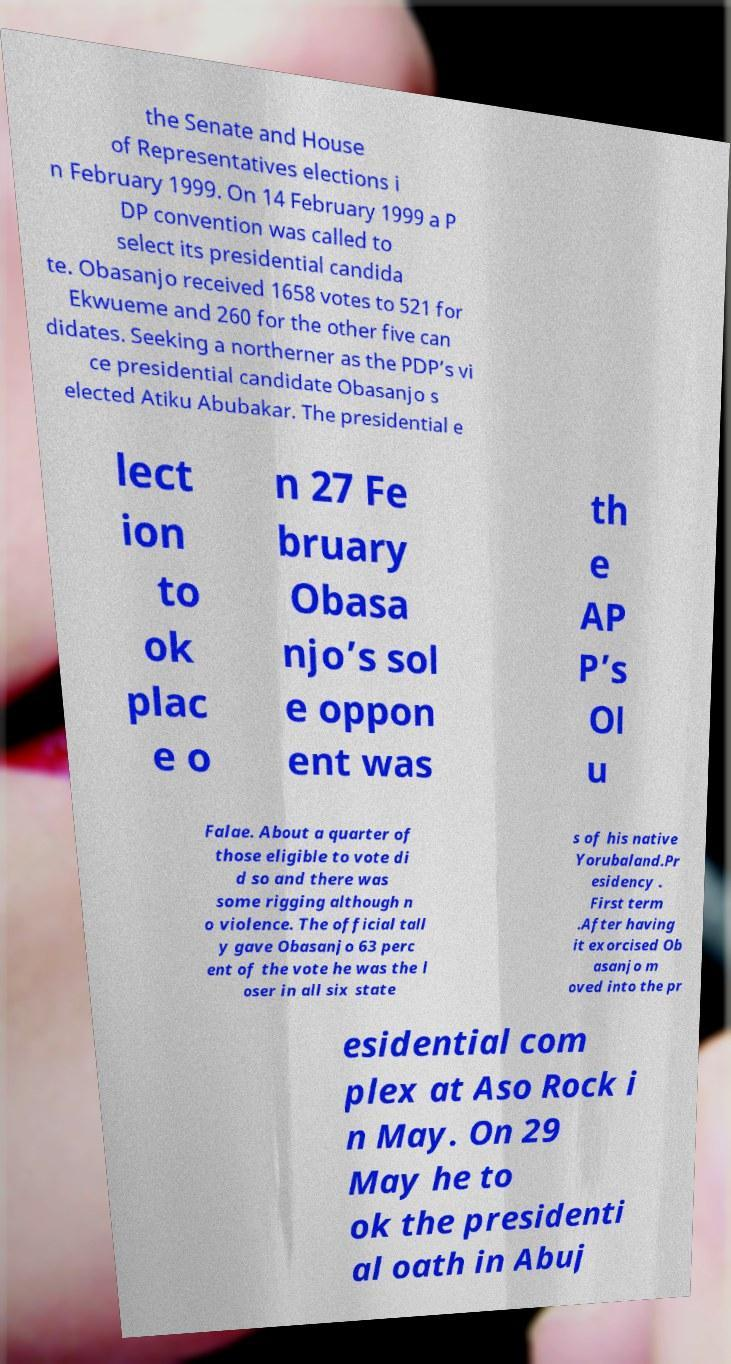What messages or text are displayed in this image? I need them in a readable, typed format. the Senate and House of Representatives elections i n February 1999. On 14 February 1999 a P DP convention was called to select its presidential candida te. Obasanjo received 1658 votes to 521 for Ekwueme and 260 for the other five can didates. Seeking a northerner as the PDP’s vi ce presidential candidate Obasanjo s elected Atiku Abubakar. The presidential e lect ion to ok plac e o n 27 Fe bruary Obasa njo’s sol e oppon ent was th e AP P’s Ol u Falae. About a quarter of those eligible to vote di d so and there was some rigging although n o violence. The official tall y gave Obasanjo 63 perc ent of the vote he was the l oser in all six state s of his native Yorubaland.Pr esidency . First term .After having it exorcised Ob asanjo m oved into the pr esidential com plex at Aso Rock i n May. On 29 May he to ok the presidenti al oath in Abuj 